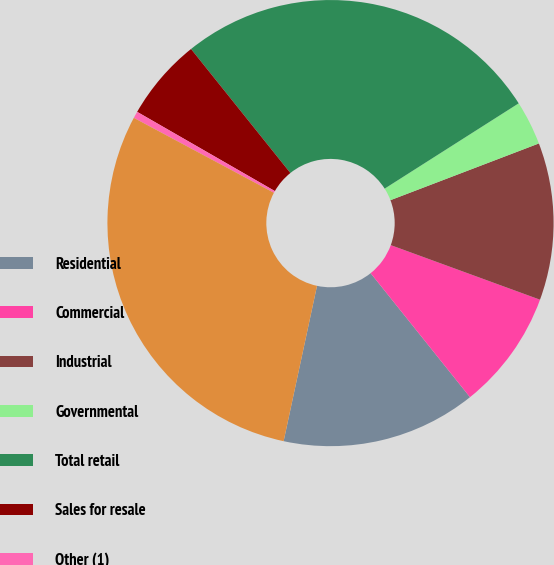Convert chart to OTSL. <chart><loc_0><loc_0><loc_500><loc_500><pie_chart><fcel>Residential<fcel>Commercial<fcel>Industrial<fcel>Governmental<fcel>Total retail<fcel>Sales for resale<fcel>Other (1)<fcel>Total<nl><fcel>14.12%<fcel>8.67%<fcel>11.39%<fcel>3.21%<fcel>26.73%<fcel>5.94%<fcel>0.49%<fcel>29.45%<nl></chart> 